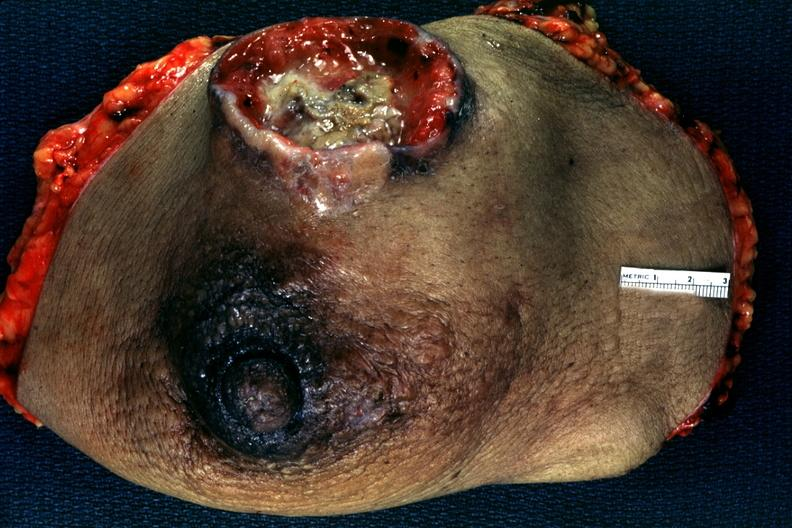where is this area in the body?
Answer the question using a single word or phrase. Breast 